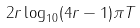<formula> <loc_0><loc_0><loc_500><loc_500>2 r \log _ { 1 0 } ( 4 r - 1 ) \pi T</formula> 